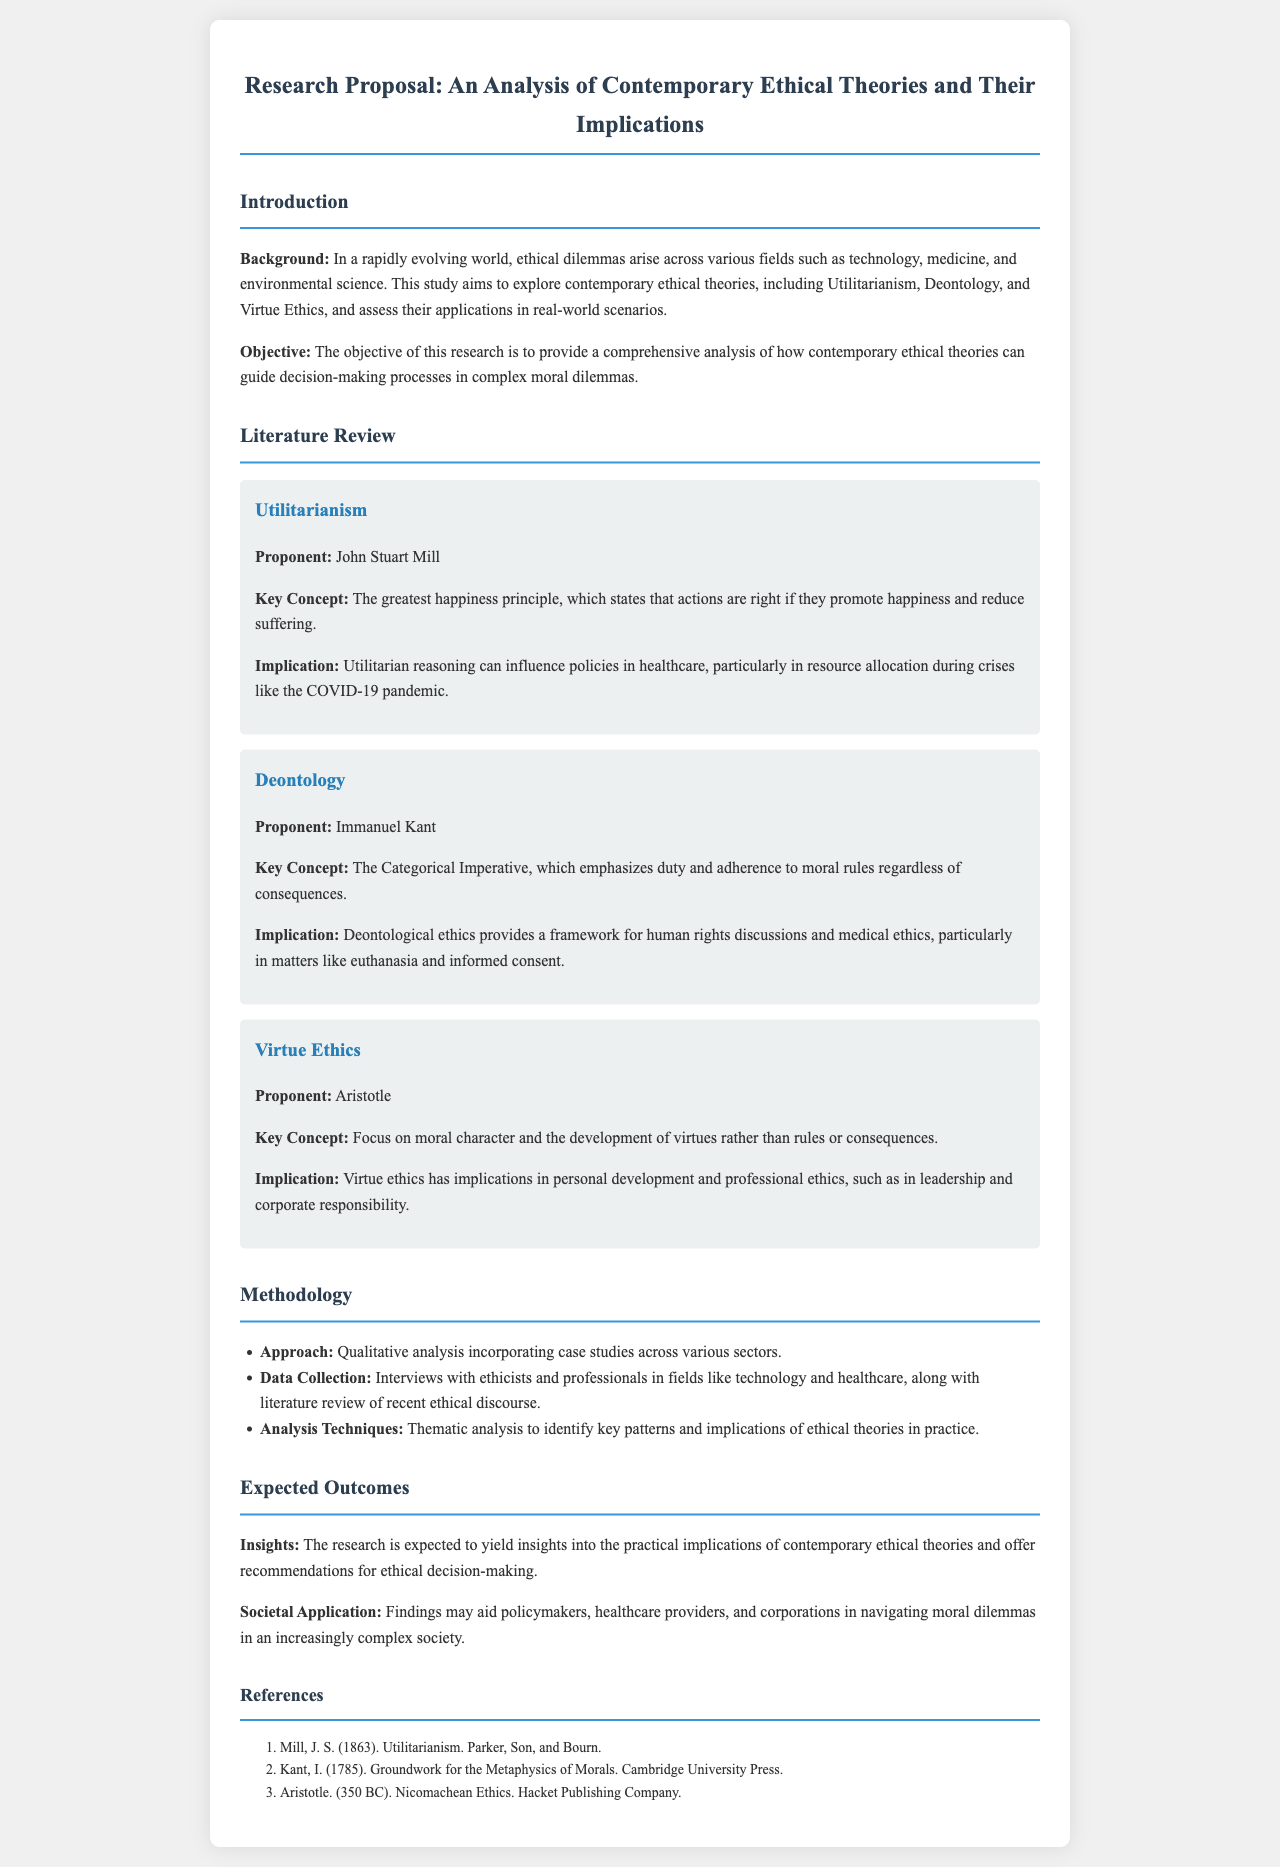What is the title of the research proposal? The title is explicitly stated at the top of the document, which is "Research Proposal: An Analysis of Contemporary Ethical Theories and Their Implications."
Answer: Research Proposal: An Analysis of Contemporary Ethical Theories and Their Implications Who is the proponent of Utilitarianism? The document lists John Stuart Mill as the proponent of Utilitarianism in the relevant section.
Answer: John Stuart Mill What is the key concept of Deontology? The key concept is highlighted in the section on Deontology, specifically mentioning the "Categorical Imperative."
Answer: Categorical Imperative What methodology approach is used in the research? The document states that a qualitative analysis incorporating case studies is used as the approach.
Answer: Qualitative analysis What are the expected insights from the research? The document mentions that the research is expected to yield insights into "the practical implications of contemporary ethical theories."
Answer: the practical implications of contemporary ethical theories Which ethical theory focuses on moral character? The section on Virtue Ethics indicates that it focuses on moral character and development of virtues.
Answer: Virtue Ethics What year was the "Groundwork for the Metaphysics of Morals" published? The document lists the publication year of Kant's work as 1785 in the references section.
Answer: 1785 Who is the proponent of Virtue Ethics? The document identifies Aristotle as the proponent of Virtue Ethics.
Answer: Aristotle 